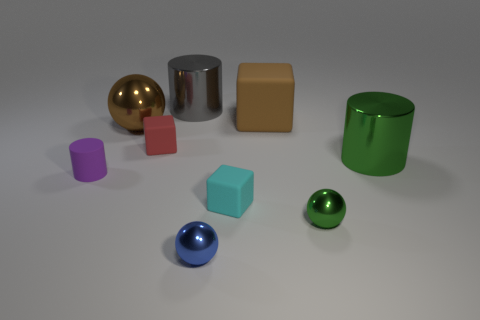The tiny cylinder has what color?
Provide a succinct answer. Purple. There is a large shiny object on the right side of the large gray cylinder; does it have the same shape as the tiny cyan rubber object?
Your answer should be compact. No. How many things are tiny metal things left of the small green sphere or small blue cylinders?
Your answer should be very brief. 1. Is there a small thing of the same shape as the large brown metallic thing?
Your answer should be compact. Yes. What shape is the green shiny object that is the same size as the gray object?
Provide a short and direct response. Cylinder. The tiny metal thing that is to the left of the tiny metallic thing that is on the right side of the brown object that is behind the big brown metal sphere is what shape?
Your answer should be very brief. Sphere. There is a cyan matte thing; is its shape the same as the brown matte thing that is behind the cyan cube?
Give a very brief answer. Yes. What number of large things are either blue cubes or shiny objects?
Your answer should be compact. 3. Is there a green cylinder of the same size as the gray cylinder?
Your answer should be compact. Yes. The small metal ball to the left of the green thing that is to the left of the shiny cylinder right of the tiny blue sphere is what color?
Provide a succinct answer. Blue. 